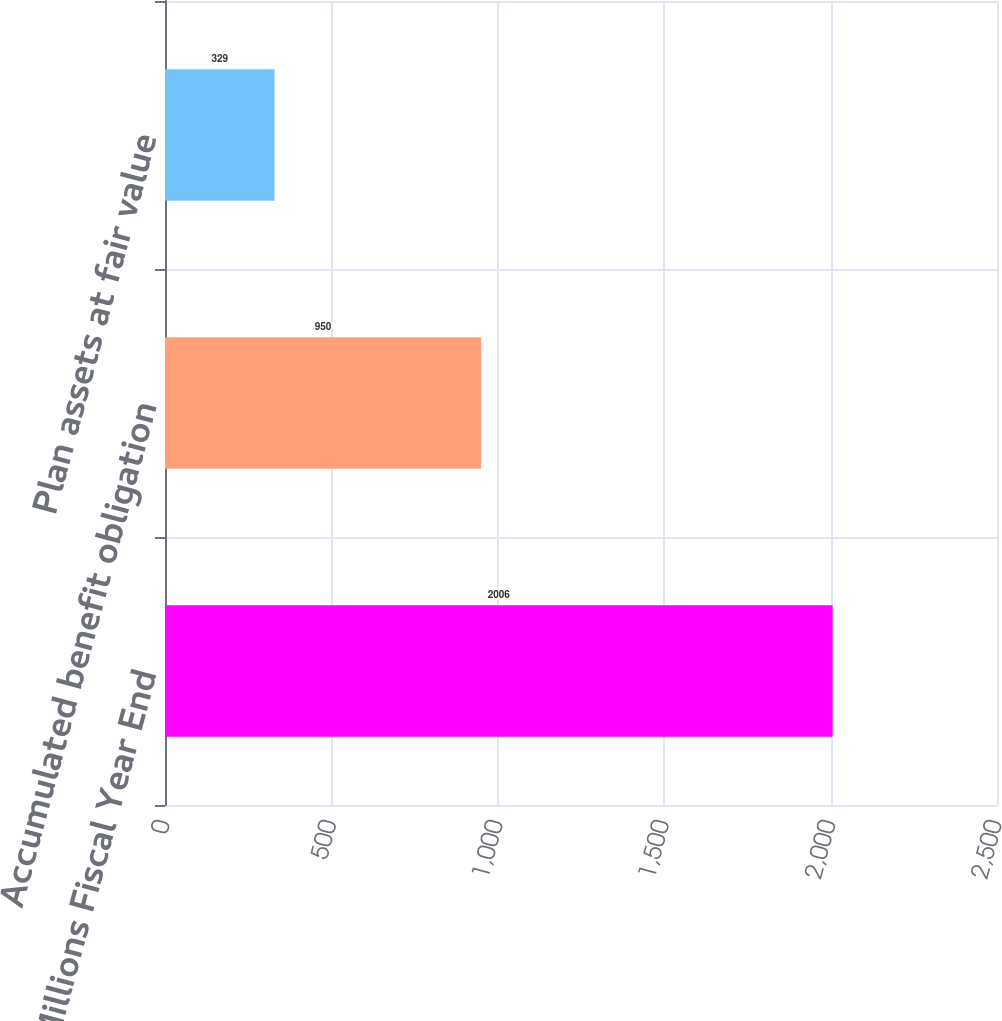<chart> <loc_0><loc_0><loc_500><loc_500><bar_chart><fcel>In Millions Fiscal Year End<fcel>Accumulated benefit obligation<fcel>Plan assets at fair value<nl><fcel>2006<fcel>950<fcel>329<nl></chart> 